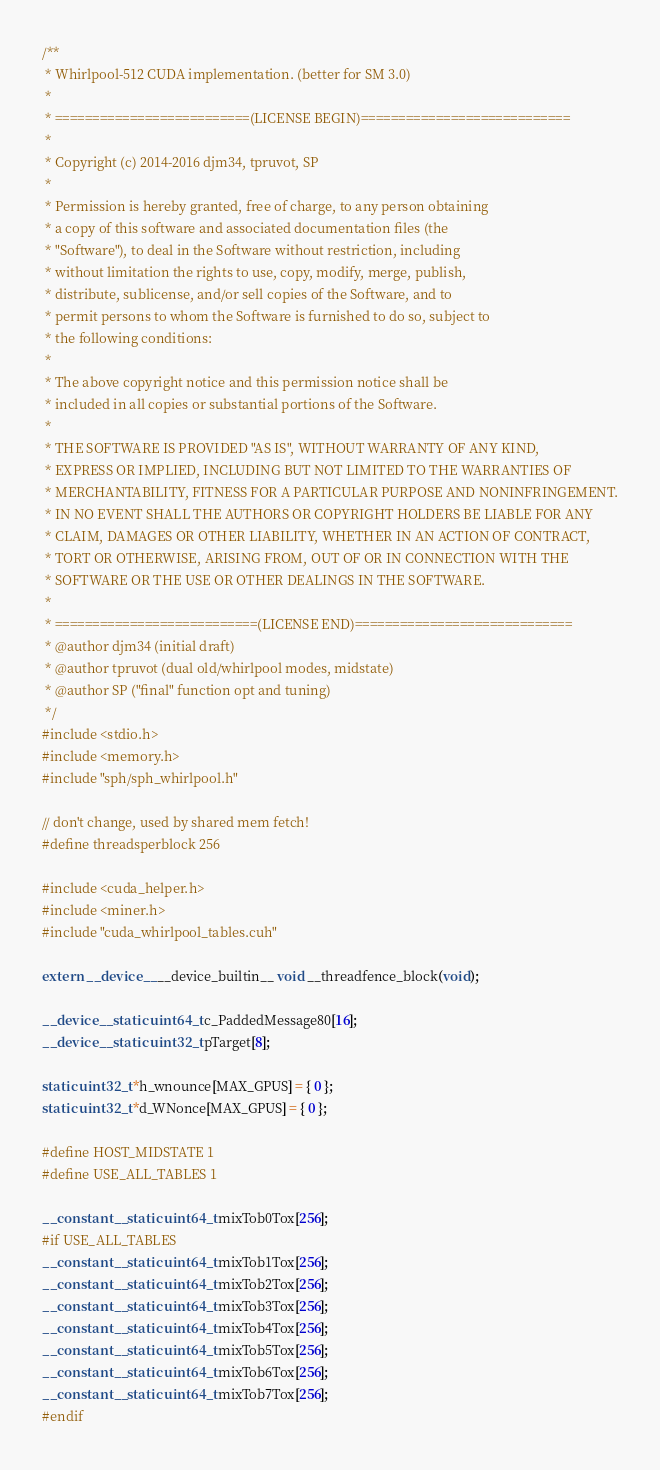<code> <loc_0><loc_0><loc_500><loc_500><_Cuda_>/**
 * Whirlpool-512 CUDA implementation. (better for SM 3.0)
 *
 * ==========================(LICENSE BEGIN)============================
 *
 * Copyright (c) 2014-2016 djm34, tpruvot, SP
 *
 * Permission is hereby granted, free of charge, to any person obtaining
 * a copy of this software and associated documentation files (the
 * "Software"), to deal in the Software without restriction, including
 * without limitation the rights to use, copy, modify, merge, publish,
 * distribute, sublicense, and/or sell copies of the Software, and to
 * permit persons to whom the Software is furnished to do so, subject to
 * the following conditions:
 *
 * The above copyright notice and this permission notice shall be
 * included in all copies or substantial portions of the Software.
 *
 * THE SOFTWARE IS PROVIDED "AS IS", WITHOUT WARRANTY OF ANY KIND,
 * EXPRESS OR IMPLIED, INCLUDING BUT NOT LIMITED TO THE WARRANTIES OF
 * MERCHANTABILITY, FITNESS FOR A PARTICULAR PURPOSE AND NONINFRINGEMENT.
 * IN NO EVENT SHALL THE AUTHORS OR COPYRIGHT HOLDERS BE LIABLE FOR ANY
 * CLAIM, DAMAGES OR OTHER LIABILITY, WHETHER IN AN ACTION OF CONTRACT,
 * TORT OR OTHERWISE, ARISING FROM, OUT OF OR IN CONNECTION WITH THE
 * SOFTWARE OR THE USE OR OTHER DEALINGS IN THE SOFTWARE.
 *
 * ===========================(LICENSE END)=============================
 * @author djm34 (initial draft)
 * @author tpruvot (dual old/whirlpool modes, midstate)
 * @author SP ("final" function opt and tuning)
 */
#include <stdio.h>
#include <memory.h>
#include "sph/sph_whirlpool.h"

// don't change, used by shared mem fetch!
#define threadsperblock 256

#include <cuda_helper.h>
#include <miner.h>
#include "cuda_whirlpool_tables.cuh"

extern __device__ __device_builtin__ void __threadfence_block(void);

__device__ static uint64_t c_PaddedMessage80[16];
__device__ static uint32_t pTarget[8];

static uint32_t *h_wnounce[MAX_GPUS] = { 0 };
static uint32_t *d_WNonce[MAX_GPUS] = { 0 };

#define HOST_MIDSTATE 1
#define USE_ALL_TABLES 1

__constant__ static uint64_t mixTob0Tox[256];
#if USE_ALL_TABLES
__constant__ static uint64_t mixTob1Tox[256];
__constant__ static uint64_t mixTob2Tox[256];
__constant__ static uint64_t mixTob3Tox[256];
__constant__ static uint64_t mixTob4Tox[256];
__constant__ static uint64_t mixTob5Tox[256];
__constant__ static uint64_t mixTob6Tox[256];
__constant__ static uint64_t mixTob7Tox[256];
#endif
</code> 